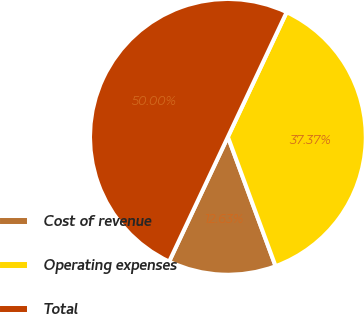Convert chart. <chart><loc_0><loc_0><loc_500><loc_500><pie_chart><fcel>Cost of revenue<fcel>Operating expenses<fcel>Total<nl><fcel>12.63%<fcel>37.37%<fcel>50.0%<nl></chart> 